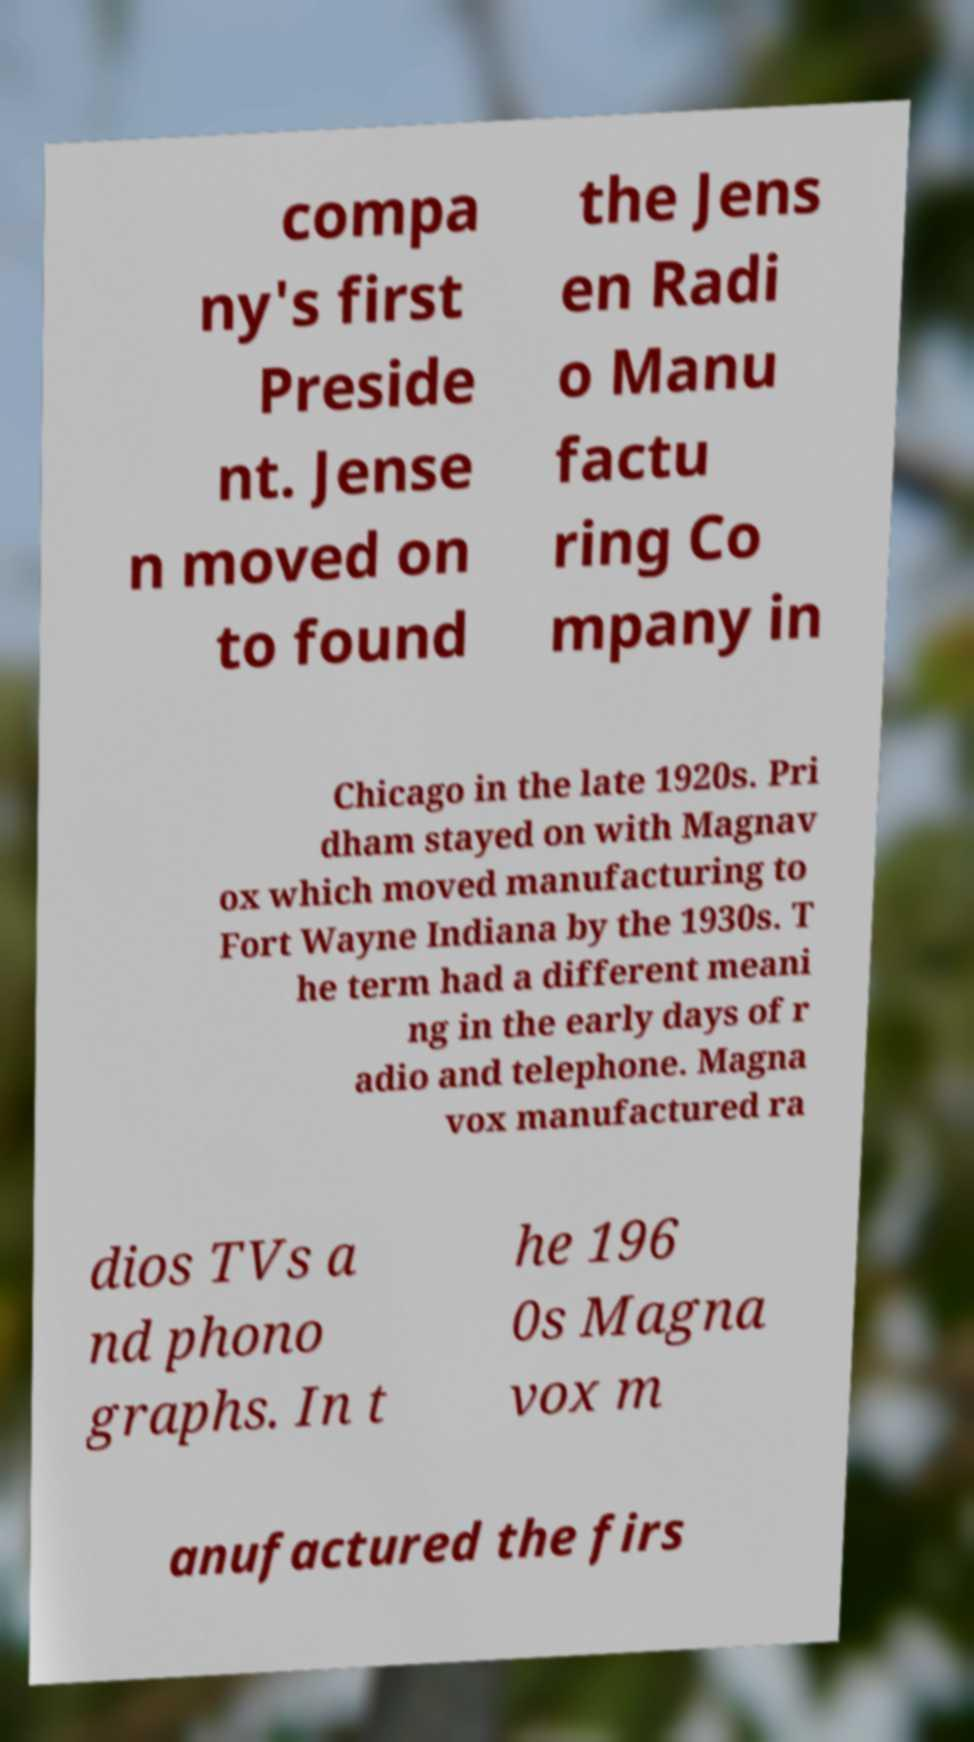There's text embedded in this image that I need extracted. Can you transcribe it verbatim? compa ny's first Preside nt. Jense n moved on to found the Jens en Radi o Manu factu ring Co mpany in Chicago in the late 1920s. Pri dham stayed on with Magnav ox which moved manufacturing to Fort Wayne Indiana by the 1930s. T he term had a different meani ng in the early days of r adio and telephone. Magna vox manufactured ra dios TVs a nd phono graphs. In t he 196 0s Magna vox m anufactured the firs 